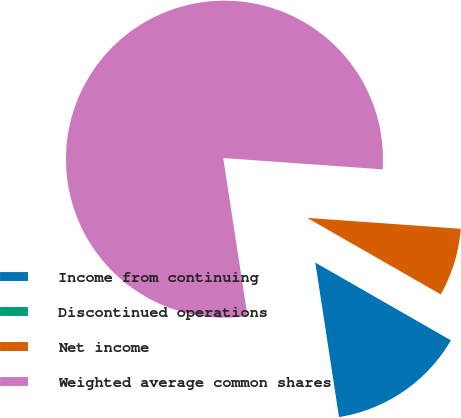Convert chart to OTSL. <chart><loc_0><loc_0><loc_500><loc_500><pie_chart><fcel>Income from continuing<fcel>Discontinued operations<fcel>Net income<fcel>Weighted average common shares<nl><fcel>14.29%<fcel>0.01%<fcel>7.15%<fcel>78.56%<nl></chart> 